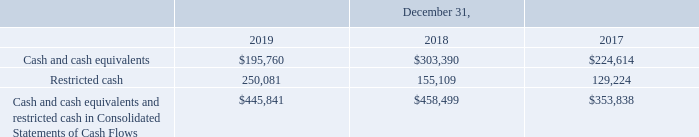GreenSky, Inc. NOTES TO CONSOLIDATED FINANCIAL STATEMENTS — (Continued) (United States Dollars in thousands, except per share data, unless otherwise stated)
Cash and Cash Equivalents
Cash includes non-interest and interest-bearing demand deposit accounts with various financial institutions. Cash equivalents include money market mutual fund accounts, which are invested in government securities. We consider all highly liquid investments that mature three months or less from the date of purchase to be cash equivalents. The carrying amounts of our cash equivalents approximate their fair values due to their short maturities and highly liquid nature. Refer to Note 3 for additional information.
At times, our cash balances may exceed federally insured amounts and potentially subject the Company to a concentration of credit risk. The Company believes that no significant concentration of credit risk exists with respect to these balances based on its assessment of the creditworthiness and financial viability of these financial institutions. Further, our cash equivalents may expose us to credit risk; however, we believe this risk is limited, as the investments are backed by the full faith and credit of the United States government.
Restricted Cash
Restricted cash primarily consists of interest-bearing escrow accounts that are required under the terms of the contracts with our Bank Partners. Restricted cash is typically comprised of three components: (i) amounts we have escrowed with Bank Partners as limited protection to the Bank Partners in the event of excess Bank Partner portfolio credit losses; (ii) additional amounts we maintain for certain Bank Partners based on a contractual percentage of the total interest billed on outstanding deferred interest loans that are within the promotional period less previous finance charge reversal ("FCR") settlements on such outstanding loans; and (iii) certain custodial intransit loan funding and consumer borrower payments that we are restricted from using for our operations. These custodial balances are not considered in our evaluation of restricted cash usage. As it relates to our restricted cash escrowed with Bank Partners, we record a liability for the amount of restricted cash we expect to be payable to our Bank Partners, which is accounted for as a financial guarantee. Refer to Note 14 for additional information.
The following table provides a reconciliation of cash and cash equivalents and restricted cash reported within the Consolidated Balance Sheets to the total included within the Consolidated Statements of Cash Flows as of the dates indicated.
What does Cash include? Non-interest and interest-bearing demand deposit accounts with various financial institutions. What was the amount of restricted cash in 2017?
Answer scale should be: thousand. 129,224. Which years does the table provide? 2019, 2018, 2017. How many years did Cash and cash equivalents and restricted cash in Consolidated Statements of Cash Flows exceed $400,000 thousand? 2019##2018
Answer: 2. What was the change in Cash and cash equivalents between 2018 and 2019?
Answer scale should be: thousand. 195,760-303,390
Answer: -107630. What was the percentage change in restricted cash between 2017 and 2018?
Answer scale should be: percent. (155,109-129,224)/129,224
Answer: 20.03. 